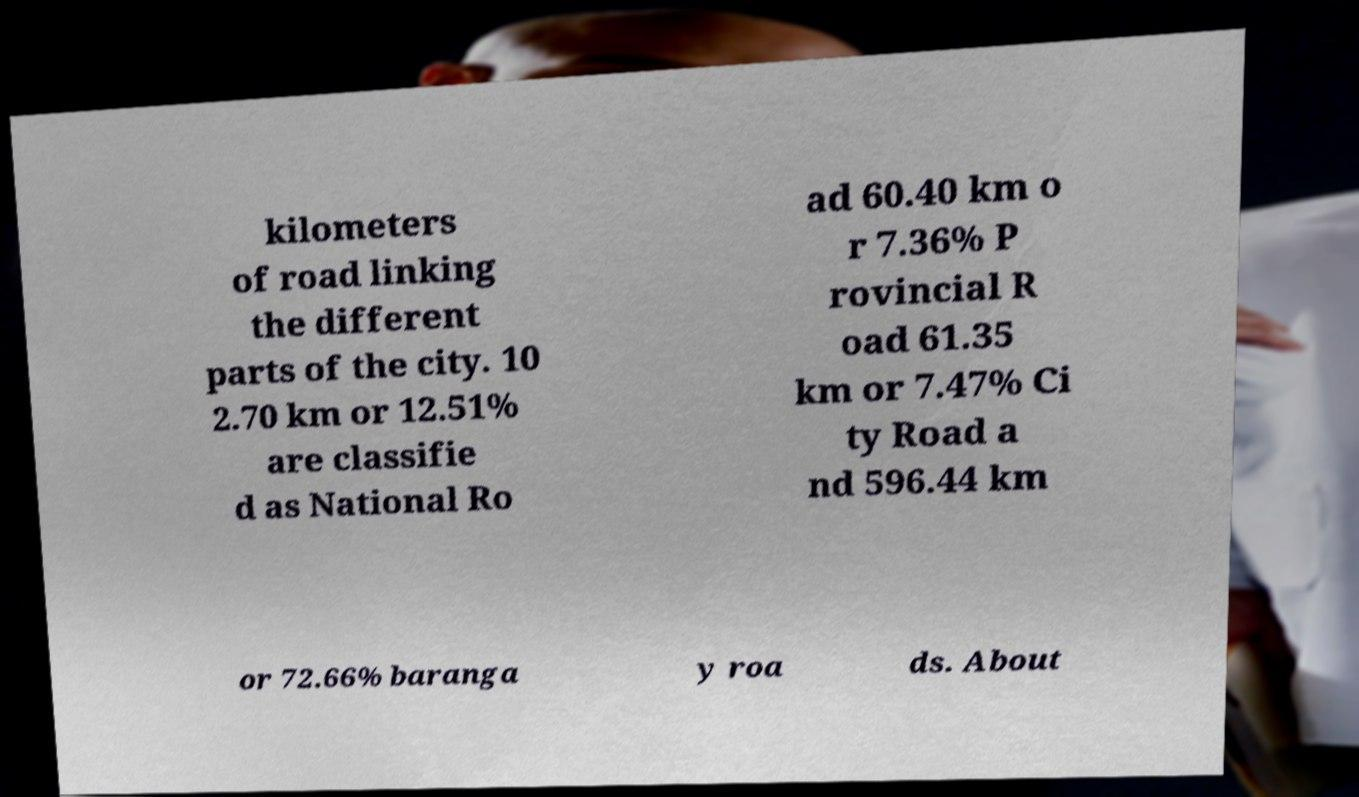Please identify and transcribe the text found in this image. kilometers of road linking the different parts of the city. 10 2.70 km or 12.51% are classifie d as National Ro ad 60.40 km o r 7.36% P rovincial R oad 61.35 km or 7.47% Ci ty Road a nd 596.44 km or 72.66% baranga y roa ds. About 